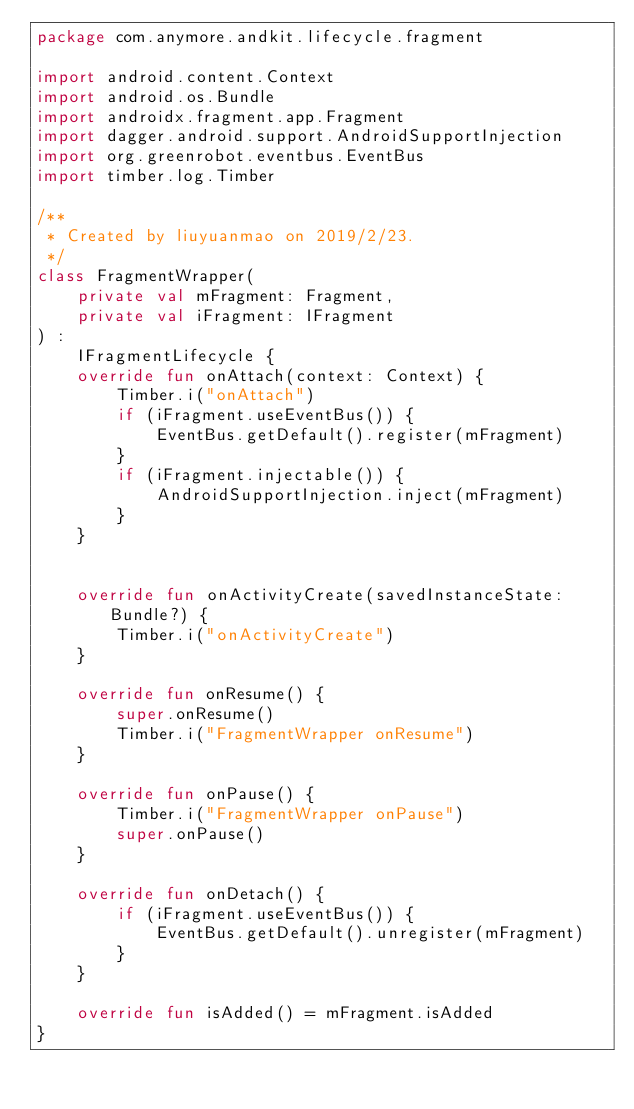<code> <loc_0><loc_0><loc_500><loc_500><_Kotlin_>package com.anymore.andkit.lifecycle.fragment

import android.content.Context
import android.os.Bundle
import androidx.fragment.app.Fragment
import dagger.android.support.AndroidSupportInjection
import org.greenrobot.eventbus.EventBus
import timber.log.Timber

/**
 * Created by liuyuanmao on 2019/2/23.
 */
class FragmentWrapper(
    private val mFragment: Fragment,
    private val iFragment: IFragment
) :
    IFragmentLifecycle {
    override fun onAttach(context: Context) {
        Timber.i("onAttach")
        if (iFragment.useEventBus()) {
            EventBus.getDefault().register(mFragment)
        }
        if (iFragment.injectable()) {
            AndroidSupportInjection.inject(mFragment)
        }
    }


    override fun onActivityCreate(savedInstanceState: Bundle?) {
        Timber.i("onActivityCreate")
    }

    override fun onResume() {
        super.onResume()
        Timber.i("FragmentWrapper onResume")
    }

    override fun onPause() {
        Timber.i("FragmentWrapper onPause")
        super.onPause()
    }

    override fun onDetach() {
        if (iFragment.useEventBus()) {
            EventBus.getDefault().unregister(mFragment)
        }
    }

    override fun isAdded() = mFragment.isAdded
}</code> 